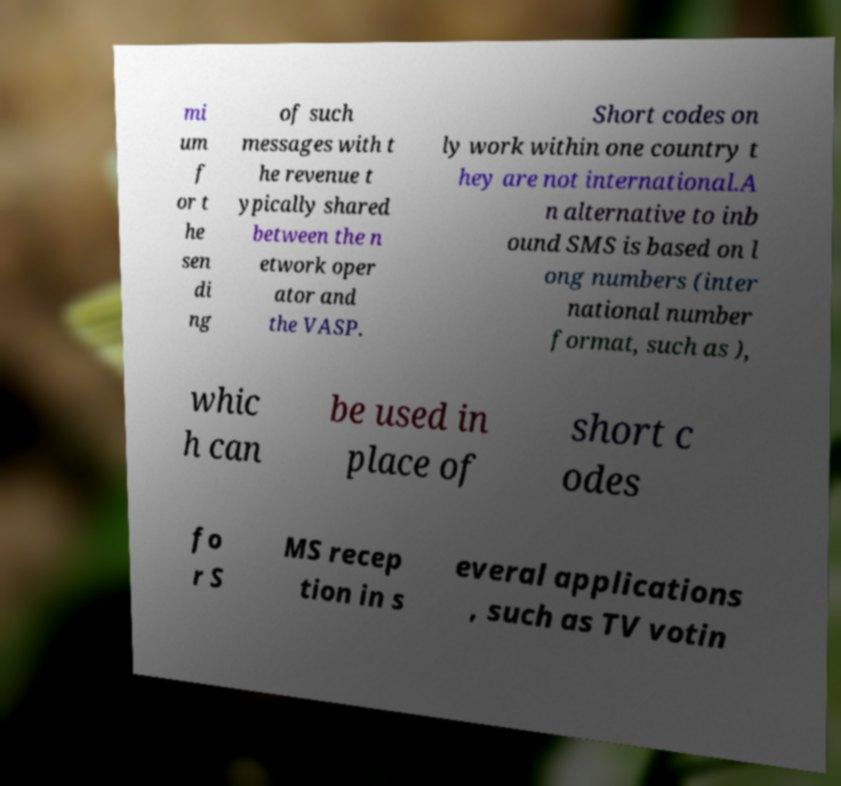Please identify and transcribe the text found in this image. mi um f or t he sen di ng of such messages with t he revenue t ypically shared between the n etwork oper ator and the VASP. Short codes on ly work within one country t hey are not international.A n alternative to inb ound SMS is based on l ong numbers (inter national number format, such as ), whic h can be used in place of short c odes fo r S MS recep tion in s everal applications , such as TV votin 